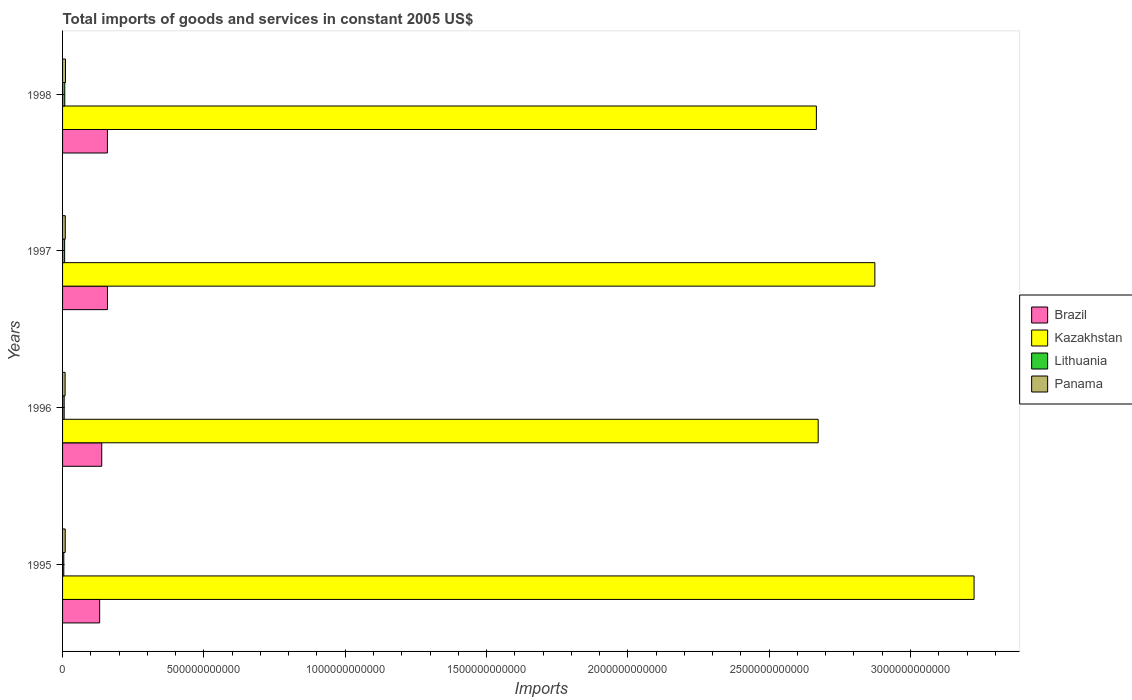How many different coloured bars are there?
Offer a terse response. 4. What is the total imports of goods and services in Lithuania in 1997?
Give a very brief answer. 7.31e+09. Across all years, what is the maximum total imports of goods and services in Lithuania?
Make the answer very short. 7.78e+09. Across all years, what is the minimum total imports of goods and services in Lithuania?
Your answer should be very brief. 4.37e+09. What is the total total imports of goods and services in Brazil in the graph?
Your answer should be compact. 5.87e+11. What is the difference between the total imports of goods and services in Kazakhstan in 1995 and that in 1998?
Keep it short and to the point. 5.58e+11. What is the difference between the total imports of goods and services in Kazakhstan in 1996 and the total imports of goods and services in Panama in 1995?
Provide a succinct answer. 2.66e+12. What is the average total imports of goods and services in Kazakhstan per year?
Provide a short and direct response. 2.86e+12. In the year 1997, what is the difference between the total imports of goods and services in Brazil and total imports of goods and services in Lithuania?
Your answer should be very brief. 1.52e+11. What is the ratio of the total imports of goods and services in Brazil in 1995 to that in 1996?
Give a very brief answer. 0.95. Is the difference between the total imports of goods and services in Brazil in 1995 and 1997 greater than the difference between the total imports of goods and services in Lithuania in 1995 and 1997?
Make the answer very short. No. What is the difference between the highest and the second highest total imports of goods and services in Kazakhstan?
Offer a very short reply. 3.51e+11. What is the difference between the highest and the lowest total imports of goods and services in Kazakhstan?
Your response must be concise. 5.58e+11. Is the sum of the total imports of goods and services in Kazakhstan in 1995 and 1998 greater than the maximum total imports of goods and services in Brazil across all years?
Give a very brief answer. Yes. What does the 1st bar from the top in 1995 represents?
Offer a terse response. Panama. What does the 4th bar from the bottom in 1997 represents?
Your response must be concise. Panama. How many bars are there?
Ensure brevity in your answer.  16. What is the difference between two consecutive major ticks on the X-axis?
Make the answer very short. 5.00e+11. Does the graph contain any zero values?
Provide a succinct answer. No. How are the legend labels stacked?
Offer a terse response. Vertical. What is the title of the graph?
Keep it short and to the point. Total imports of goods and services in constant 2005 US$. Does "Russian Federation" appear as one of the legend labels in the graph?
Your response must be concise. No. What is the label or title of the X-axis?
Keep it short and to the point. Imports. What is the Imports in Brazil in 1995?
Your response must be concise. 1.31e+11. What is the Imports in Kazakhstan in 1995?
Provide a succinct answer. 3.22e+12. What is the Imports of Lithuania in 1995?
Your answer should be compact. 4.37e+09. What is the Imports in Panama in 1995?
Provide a short and direct response. 9.39e+09. What is the Imports in Brazil in 1996?
Provide a short and direct response. 1.39e+11. What is the Imports of Kazakhstan in 1996?
Your response must be concise. 2.67e+12. What is the Imports of Lithuania in 1996?
Offer a very short reply. 5.66e+09. What is the Imports in Panama in 1996?
Your answer should be compact. 9.00e+09. What is the Imports of Brazil in 1997?
Provide a succinct answer. 1.59e+11. What is the Imports of Kazakhstan in 1997?
Your response must be concise. 2.87e+12. What is the Imports in Lithuania in 1997?
Ensure brevity in your answer.  7.31e+09. What is the Imports of Panama in 1997?
Make the answer very short. 9.63e+09. What is the Imports of Brazil in 1998?
Make the answer very short. 1.59e+11. What is the Imports in Kazakhstan in 1998?
Your answer should be very brief. 2.67e+12. What is the Imports of Lithuania in 1998?
Offer a terse response. 7.78e+09. What is the Imports of Panama in 1998?
Make the answer very short. 1.04e+1. Across all years, what is the maximum Imports of Brazil?
Provide a short and direct response. 1.59e+11. Across all years, what is the maximum Imports in Kazakhstan?
Make the answer very short. 3.22e+12. Across all years, what is the maximum Imports in Lithuania?
Your answer should be very brief. 7.78e+09. Across all years, what is the maximum Imports in Panama?
Keep it short and to the point. 1.04e+1. Across all years, what is the minimum Imports of Brazil?
Offer a very short reply. 1.31e+11. Across all years, what is the minimum Imports in Kazakhstan?
Make the answer very short. 2.67e+12. Across all years, what is the minimum Imports in Lithuania?
Give a very brief answer. 4.37e+09. Across all years, what is the minimum Imports in Panama?
Make the answer very short. 9.00e+09. What is the total Imports in Brazil in the graph?
Your response must be concise. 5.87e+11. What is the total Imports in Kazakhstan in the graph?
Provide a short and direct response. 1.14e+13. What is the total Imports of Lithuania in the graph?
Your response must be concise. 2.51e+1. What is the total Imports in Panama in the graph?
Your answer should be compact. 3.84e+1. What is the difference between the Imports of Brazil in 1995 and that in 1996?
Offer a terse response. -7.34e+09. What is the difference between the Imports in Kazakhstan in 1995 and that in 1996?
Offer a very short reply. 5.51e+11. What is the difference between the Imports in Lithuania in 1995 and that in 1996?
Offer a very short reply. -1.29e+09. What is the difference between the Imports in Panama in 1995 and that in 1996?
Keep it short and to the point. 3.87e+08. What is the difference between the Imports in Brazil in 1995 and that in 1997?
Your response must be concise. -2.76e+1. What is the difference between the Imports in Kazakhstan in 1995 and that in 1997?
Make the answer very short. 3.51e+11. What is the difference between the Imports of Lithuania in 1995 and that in 1997?
Offer a terse response. -2.94e+09. What is the difference between the Imports in Panama in 1995 and that in 1997?
Your answer should be very brief. -2.41e+08. What is the difference between the Imports of Brazil in 1995 and that in 1998?
Provide a succinct answer. -2.75e+1. What is the difference between the Imports of Kazakhstan in 1995 and that in 1998?
Your response must be concise. 5.58e+11. What is the difference between the Imports of Lithuania in 1995 and that in 1998?
Your answer should be compact. -3.41e+09. What is the difference between the Imports in Panama in 1995 and that in 1998?
Your answer should be compact. -9.90e+08. What is the difference between the Imports of Brazil in 1996 and that in 1997?
Provide a succinct answer. -2.02e+1. What is the difference between the Imports in Kazakhstan in 1996 and that in 1997?
Provide a succinct answer. -2.01e+11. What is the difference between the Imports in Lithuania in 1996 and that in 1997?
Your answer should be very brief. -1.65e+09. What is the difference between the Imports in Panama in 1996 and that in 1997?
Your response must be concise. -6.28e+08. What is the difference between the Imports in Brazil in 1996 and that in 1998?
Keep it short and to the point. -2.01e+1. What is the difference between the Imports in Kazakhstan in 1996 and that in 1998?
Your answer should be very brief. 6.42e+09. What is the difference between the Imports in Lithuania in 1996 and that in 1998?
Provide a short and direct response. -2.12e+09. What is the difference between the Imports in Panama in 1996 and that in 1998?
Offer a very short reply. -1.38e+09. What is the difference between the Imports in Brazil in 1997 and that in 1998?
Provide a short and direct response. 9.24e+07. What is the difference between the Imports of Kazakhstan in 1997 and that in 1998?
Provide a succinct answer. 2.07e+11. What is the difference between the Imports in Lithuania in 1997 and that in 1998?
Your answer should be very brief. -4.70e+08. What is the difference between the Imports of Panama in 1997 and that in 1998?
Your answer should be compact. -7.49e+08. What is the difference between the Imports of Brazil in 1995 and the Imports of Kazakhstan in 1996?
Keep it short and to the point. -2.54e+12. What is the difference between the Imports of Brazil in 1995 and the Imports of Lithuania in 1996?
Provide a short and direct response. 1.26e+11. What is the difference between the Imports of Brazil in 1995 and the Imports of Panama in 1996?
Provide a succinct answer. 1.22e+11. What is the difference between the Imports in Kazakhstan in 1995 and the Imports in Lithuania in 1996?
Offer a very short reply. 3.22e+12. What is the difference between the Imports of Kazakhstan in 1995 and the Imports of Panama in 1996?
Keep it short and to the point. 3.22e+12. What is the difference between the Imports in Lithuania in 1995 and the Imports in Panama in 1996?
Offer a terse response. -4.63e+09. What is the difference between the Imports in Brazil in 1995 and the Imports in Kazakhstan in 1997?
Provide a succinct answer. -2.74e+12. What is the difference between the Imports of Brazil in 1995 and the Imports of Lithuania in 1997?
Give a very brief answer. 1.24e+11. What is the difference between the Imports of Brazil in 1995 and the Imports of Panama in 1997?
Provide a succinct answer. 1.22e+11. What is the difference between the Imports of Kazakhstan in 1995 and the Imports of Lithuania in 1997?
Your response must be concise. 3.22e+12. What is the difference between the Imports of Kazakhstan in 1995 and the Imports of Panama in 1997?
Your response must be concise. 3.22e+12. What is the difference between the Imports in Lithuania in 1995 and the Imports in Panama in 1997?
Your answer should be very brief. -5.26e+09. What is the difference between the Imports of Brazil in 1995 and the Imports of Kazakhstan in 1998?
Give a very brief answer. -2.54e+12. What is the difference between the Imports of Brazil in 1995 and the Imports of Lithuania in 1998?
Provide a succinct answer. 1.23e+11. What is the difference between the Imports in Brazil in 1995 and the Imports in Panama in 1998?
Make the answer very short. 1.21e+11. What is the difference between the Imports of Kazakhstan in 1995 and the Imports of Lithuania in 1998?
Offer a very short reply. 3.22e+12. What is the difference between the Imports in Kazakhstan in 1995 and the Imports in Panama in 1998?
Your answer should be very brief. 3.21e+12. What is the difference between the Imports of Lithuania in 1995 and the Imports of Panama in 1998?
Ensure brevity in your answer.  -6.01e+09. What is the difference between the Imports of Brazil in 1996 and the Imports of Kazakhstan in 1997?
Offer a very short reply. -2.74e+12. What is the difference between the Imports in Brazil in 1996 and the Imports in Lithuania in 1997?
Make the answer very short. 1.31e+11. What is the difference between the Imports of Brazil in 1996 and the Imports of Panama in 1997?
Give a very brief answer. 1.29e+11. What is the difference between the Imports in Kazakhstan in 1996 and the Imports in Lithuania in 1997?
Offer a terse response. 2.67e+12. What is the difference between the Imports in Kazakhstan in 1996 and the Imports in Panama in 1997?
Ensure brevity in your answer.  2.66e+12. What is the difference between the Imports of Lithuania in 1996 and the Imports of Panama in 1997?
Your answer should be compact. -3.97e+09. What is the difference between the Imports of Brazil in 1996 and the Imports of Kazakhstan in 1998?
Keep it short and to the point. -2.53e+12. What is the difference between the Imports of Brazil in 1996 and the Imports of Lithuania in 1998?
Offer a very short reply. 1.31e+11. What is the difference between the Imports in Brazil in 1996 and the Imports in Panama in 1998?
Make the answer very short. 1.28e+11. What is the difference between the Imports in Kazakhstan in 1996 and the Imports in Lithuania in 1998?
Your response must be concise. 2.67e+12. What is the difference between the Imports of Kazakhstan in 1996 and the Imports of Panama in 1998?
Your answer should be very brief. 2.66e+12. What is the difference between the Imports in Lithuania in 1996 and the Imports in Panama in 1998?
Provide a succinct answer. -4.72e+09. What is the difference between the Imports of Brazil in 1997 and the Imports of Kazakhstan in 1998?
Provide a succinct answer. -2.51e+12. What is the difference between the Imports of Brazil in 1997 and the Imports of Lithuania in 1998?
Offer a terse response. 1.51e+11. What is the difference between the Imports in Brazil in 1997 and the Imports in Panama in 1998?
Your response must be concise. 1.48e+11. What is the difference between the Imports of Kazakhstan in 1997 and the Imports of Lithuania in 1998?
Give a very brief answer. 2.87e+12. What is the difference between the Imports of Kazakhstan in 1997 and the Imports of Panama in 1998?
Your response must be concise. 2.86e+12. What is the difference between the Imports of Lithuania in 1997 and the Imports of Panama in 1998?
Your response must be concise. -3.07e+09. What is the average Imports in Brazil per year?
Ensure brevity in your answer.  1.47e+11. What is the average Imports of Kazakhstan per year?
Your answer should be very brief. 2.86e+12. What is the average Imports in Lithuania per year?
Provide a short and direct response. 6.28e+09. What is the average Imports of Panama per year?
Give a very brief answer. 9.60e+09. In the year 1995, what is the difference between the Imports of Brazil and Imports of Kazakhstan?
Offer a terse response. -3.09e+12. In the year 1995, what is the difference between the Imports of Brazil and Imports of Lithuania?
Ensure brevity in your answer.  1.27e+11. In the year 1995, what is the difference between the Imports of Brazil and Imports of Panama?
Offer a terse response. 1.22e+11. In the year 1995, what is the difference between the Imports of Kazakhstan and Imports of Lithuania?
Your answer should be very brief. 3.22e+12. In the year 1995, what is the difference between the Imports of Kazakhstan and Imports of Panama?
Offer a terse response. 3.22e+12. In the year 1995, what is the difference between the Imports in Lithuania and Imports in Panama?
Give a very brief answer. -5.02e+09. In the year 1996, what is the difference between the Imports of Brazil and Imports of Kazakhstan?
Provide a short and direct response. -2.53e+12. In the year 1996, what is the difference between the Imports in Brazil and Imports in Lithuania?
Offer a very short reply. 1.33e+11. In the year 1996, what is the difference between the Imports of Brazil and Imports of Panama?
Provide a short and direct response. 1.30e+11. In the year 1996, what is the difference between the Imports in Kazakhstan and Imports in Lithuania?
Keep it short and to the point. 2.67e+12. In the year 1996, what is the difference between the Imports of Kazakhstan and Imports of Panama?
Provide a succinct answer. 2.66e+12. In the year 1996, what is the difference between the Imports in Lithuania and Imports in Panama?
Give a very brief answer. -3.34e+09. In the year 1997, what is the difference between the Imports in Brazil and Imports in Kazakhstan?
Offer a very short reply. -2.72e+12. In the year 1997, what is the difference between the Imports in Brazil and Imports in Lithuania?
Ensure brevity in your answer.  1.52e+11. In the year 1997, what is the difference between the Imports in Brazil and Imports in Panama?
Your answer should be compact. 1.49e+11. In the year 1997, what is the difference between the Imports in Kazakhstan and Imports in Lithuania?
Your answer should be compact. 2.87e+12. In the year 1997, what is the difference between the Imports of Kazakhstan and Imports of Panama?
Make the answer very short. 2.86e+12. In the year 1997, what is the difference between the Imports in Lithuania and Imports in Panama?
Make the answer very short. -2.32e+09. In the year 1998, what is the difference between the Imports of Brazil and Imports of Kazakhstan?
Your answer should be compact. -2.51e+12. In the year 1998, what is the difference between the Imports of Brazil and Imports of Lithuania?
Provide a short and direct response. 1.51e+11. In the year 1998, what is the difference between the Imports in Brazil and Imports in Panama?
Offer a very short reply. 1.48e+11. In the year 1998, what is the difference between the Imports of Kazakhstan and Imports of Lithuania?
Offer a terse response. 2.66e+12. In the year 1998, what is the difference between the Imports in Kazakhstan and Imports in Panama?
Ensure brevity in your answer.  2.66e+12. In the year 1998, what is the difference between the Imports of Lithuania and Imports of Panama?
Make the answer very short. -2.60e+09. What is the ratio of the Imports in Brazil in 1995 to that in 1996?
Your answer should be very brief. 0.95. What is the ratio of the Imports in Kazakhstan in 1995 to that in 1996?
Offer a very short reply. 1.21. What is the ratio of the Imports of Lithuania in 1995 to that in 1996?
Keep it short and to the point. 0.77. What is the ratio of the Imports of Panama in 1995 to that in 1996?
Your answer should be compact. 1.04. What is the ratio of the Imports in Brazil in 1995 to that in 1997?
Give a very brief answer. 0.83. What is the ratio of the Imports in Kazakhstan in 1995 to that in 1997?
Provide a succinct answer. 1.12. What is the ratio of the Imports in Lithuania in 1995 to that in 1997?
Your answer should be compact. 0.6. What is the ratio of the Imports in Panama in 1995 to that in 1997?
Provide a short and direct response. 0.97. What is the ratio of the Imports in Brazil in 1995 to that in 1998?
Offer a terse response. 0.83. What is the ratio of the Imports of Kazakhstan in 1995 to that in 1998?
Make the answer very short. 1.21. What is the ratio of the Imports in Lithuania in 1995 to that in 1998?
Your response must be concise. 0.56. What is the ratio of the Imports in Panama in 1995 to that in 1998?
Keep it short and to the point. 0.9. What is the ratio of the Imports of Brazil in 1996 to that in 1997?
Your answer should be very brief. 0.87. What is the ratio of the Imports in Kazakhstan in 1996 to that in 1997?
Offer a terse response. 0.93. What is the ratio of the Imports of Lithuania in 1996 to that in 1997?
Offer a terse response. 0.77. What is the ratio of the Imports in Panama in 1996 to that in 1997?
Make the answer very short. 0.93. What is the ratio of the Imports of Brazil in 1996 to that in 1998?
Give a very brief answer. 0.87. What is the ratio of the Imports in Lithuania in 1996 to that in 1998?
Provide a succinct answer. 0.73. What is the ratio of the Imports of Panama in 1996 to that in 1998?
Your response must be concise. 0.87. What is the ratio of the Imports in Kazakhstan in 1997 to that in 1998?
Your response must be concise. 1.08. What is the ratio of the Imports in Lithuania in 1997 to that in 1998?
Your answer should be very brief. 0.94. What is the ratio of the Imports in Panama in 1997 to that in 1998?
Provide a short and direct response. 0.93. What is the difference between the highest and the second highest Imports of Brazil?
Your answer should be compact. 9.24e+07. What is the difference between the highest and the second highest Imports of Kazakhstan?
Provide a short and direct response. 3.51e+11. What is the difference between the highest and the second highest Imports of Lithuania?
Give a very brief answer. 4.70e+08. What is the difference between the highest and the second highest Imports in Panama?
Offer a very short reply. 7.49e+08. What is the difference between the highest and the lowest Imports of Brazil?
Provide a succinct answer. 2.76e+1. What is the difference between the highest and the lowest Imports of Kazakhstan?
Keep it short and to the point. 5.58e+11. What is the difference between the highest and the lowest Imports of Lithuania?
Your answer should be compact. 3.41e+09. What is the difference between the highest and the lowest Imports of Panama?
Offer a terse response. 1.38e+09. 